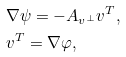Convert formula to latex. <formula><loc_0><loc_0><loc_500><loc_500>& \nabla \psi = - A _ { v ^ { \perp } } v ^ { T } , \\ & v ^ { T } = \nabla \varphi ,</formula> 